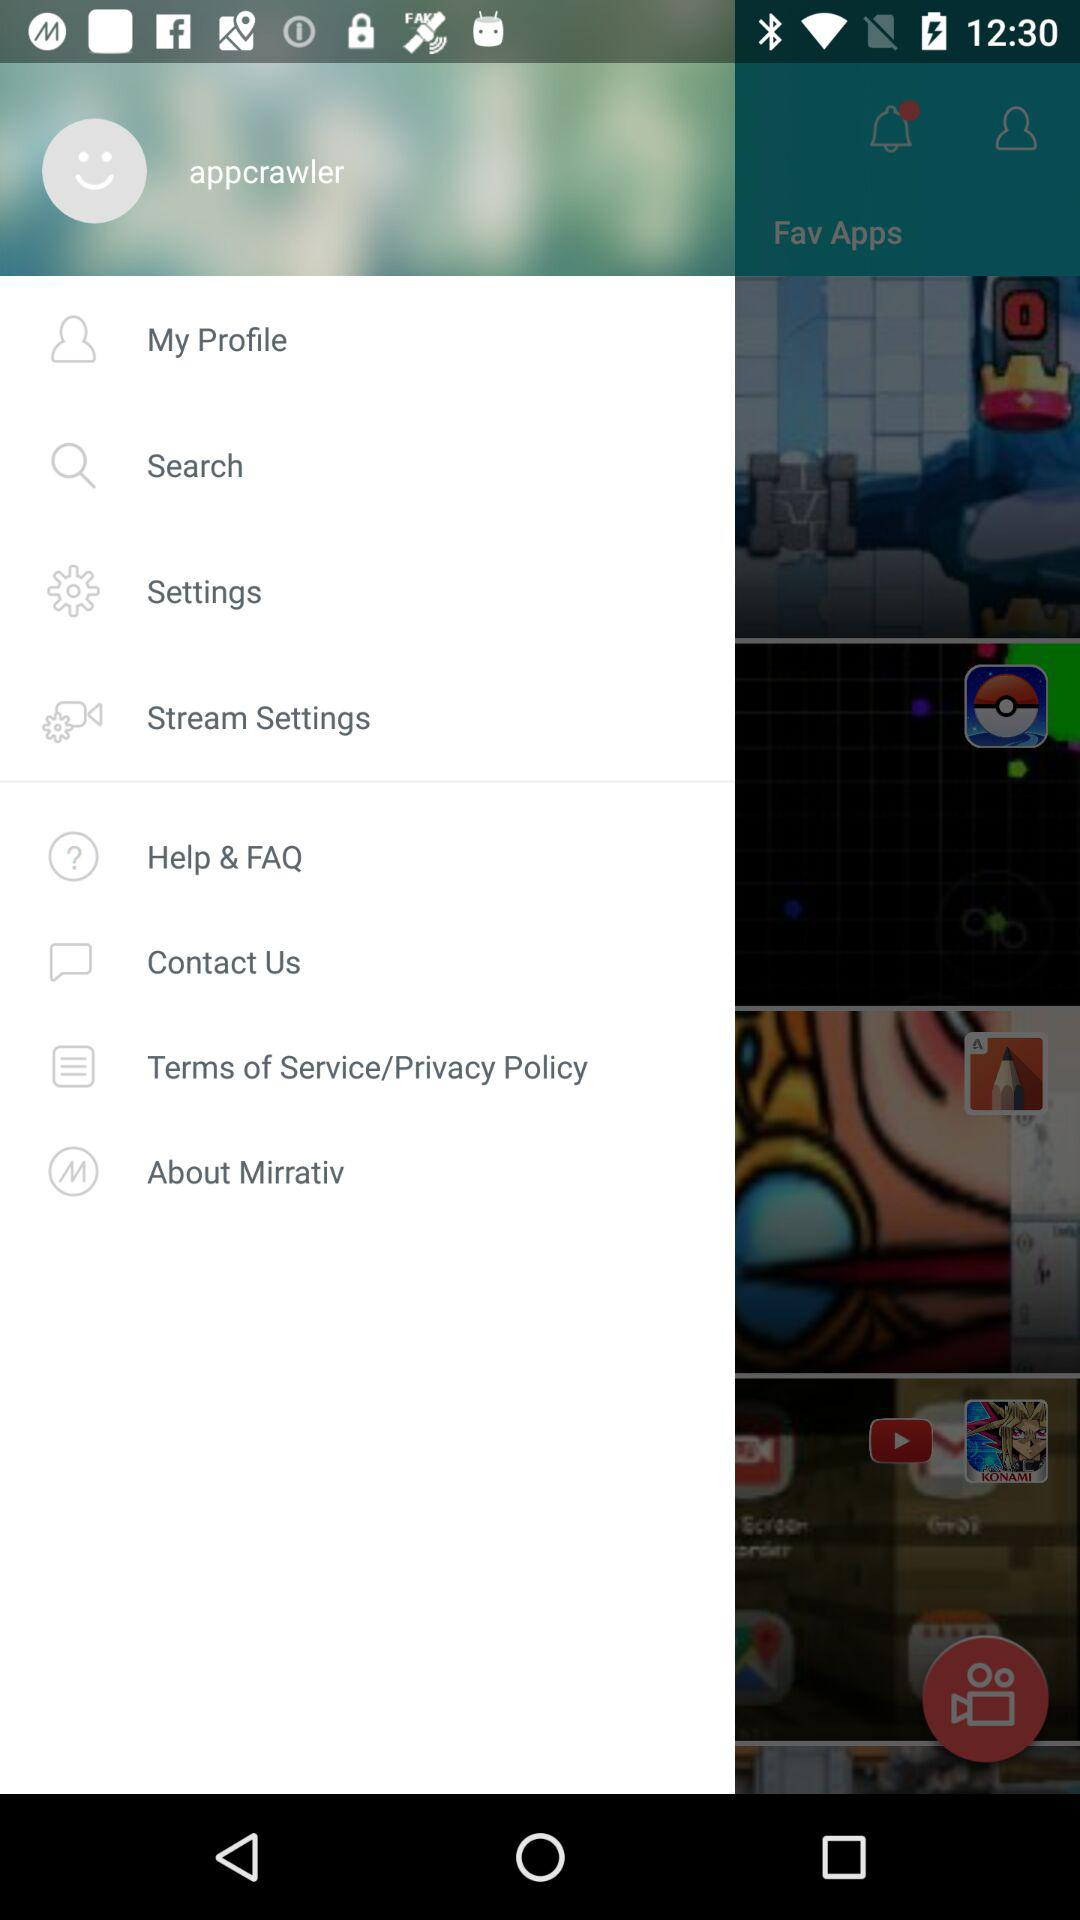What is the username? The username is "appcrawler". 